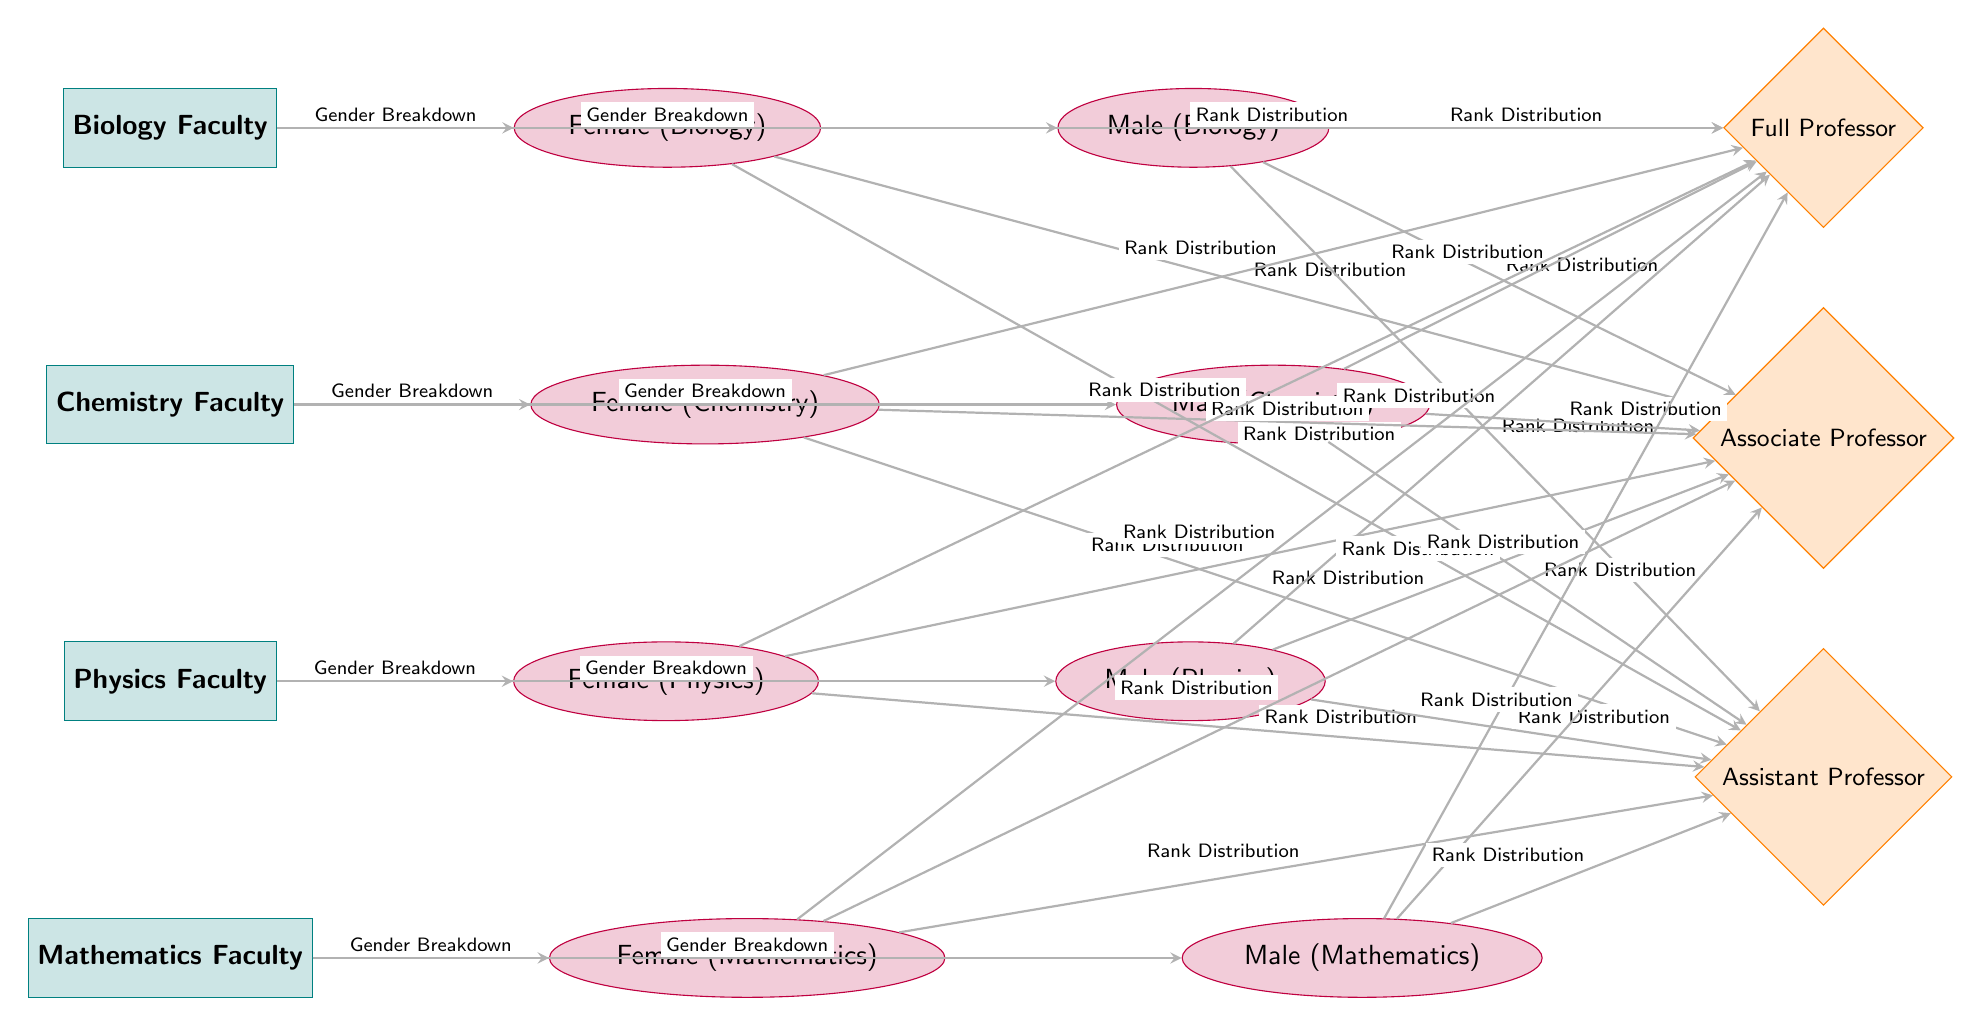What faculties are represented in the diagram? The diagram includes four faculties: Biology, Chemistry, Physics, and Mathematics. These faculties are visually listed as separate rectangular nodes that indicate the different areas of natural science.
Answer: Biology, Chemistry, Physics, Mathematics How many gender categories are shown for each faculty? Each faculty features two gender categories: Female and Male, represented as elliptical nodes next to each faculty node. Since there are four faculties, the total number of gender categories displayed is 8 (2 for each of the 4 faculties).
Answer: 8 Which gender category is associated with the highest academic rank? The rank nodes demonstrate that both Male and Female categories have connections to all three rank tiers (Full, Associate, Assistant Professor). However, there are no distinctions in the rank between genders in this diagram. Both genders can be Full Professors, but the question asks for the category mentioning the highest academic rank, which is Full Professor.
Answer: Full Professor What is the relationship between Female (Biology) and the rank structure? Female (Biology) is connected to all three ranks: Full Professor, Associate Professor, and Assistant Professor, showing the distribution of ranks available to females in the biology faculty. By following the edge connections, we see that Female (Biology) has flow lines extending to each rank node.
Answer: Full Professor, Associate Professor, Assistant Professor Which faculty has the least representation in terms of gender breakdown? The diagram does not provide specific representation numbers or visual sizes for each gender, so one cannot determine which faculty is least represented purely from the visual cues in the diagram. Since all faculties have an equal structure of gender distribution, one can assume the faculty representation is balanced unless further data is provided.
Answer: Cannot determine What is the symbolic meaning of the diagram's edges? The edges signify relationships; specifically, they denote the "Gender Breakdown" between each faculty and its gender categories and the "Rank Distribution" between each gender category and the ranks available. Each arrow illustrates a flow of information and connections between the different types of nodes in the diagram.
Answer: Relationships How do the ranks for males in Physics compare to those for females in Chemistry? Males in Physics, as well as females in Chemistry, have connections that indicate they can attain all three ranks demonstrated in the diagram. There are no visual or numerical distinctions made between the ranks for these two groups in the diagram, indicating similar rank distributions.
Answer: Same rank distribution Which gender has more options for achieving a full professorship according to the diagram? Both genders (Male and Female) are connected to the Full Professor rank, indicating that the opportunity for reaching this rank level is available to both. Thus, the diagram does not indicate a difference in options based on gender for achieving a full professorship.
Answer: Same opportunities 